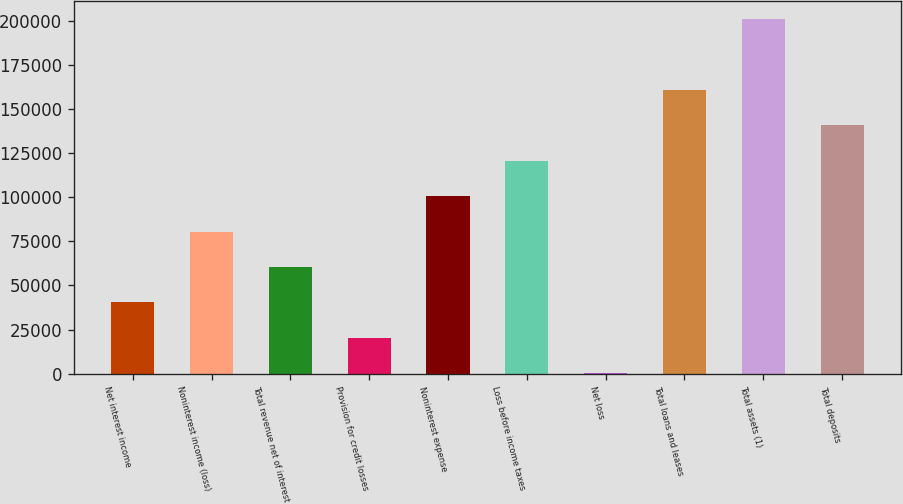Convert chart. <chart><loc_0><loc_0><loc_500><loc_500><bar_chart><fcel>Net interest income<fcel>Noninterest income (loss)<fcel>Total revenue net of interest<fcel>Provision for credit losses<fcel>Noninterest expense<fcel>Loss before income taxes<fcel>Net loss<fcel>Total loans and leases<fcel>Total assets (1)<fcel>Total deposits<nl><fcel>40350<fcel>80587<fcel>60468.5<fcel>20231.5<fcel>100706<fcel>120824<fcel>113<fcel>161061<fcel>201298<fcel>140942<nl></chart> 